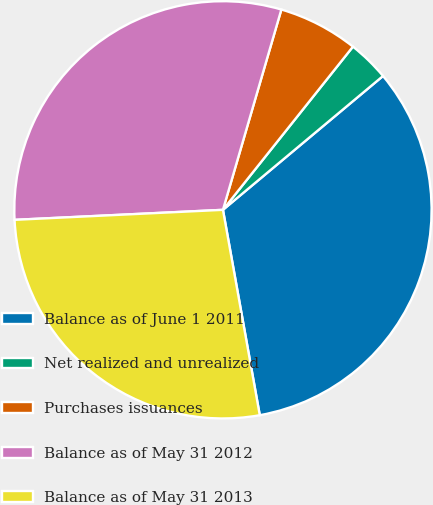Convert chart. <chart><loc_0><loc_0><loc_500><loc_500><pie_chart><fcel>Balance as of June 1 2011<fcel>Net realized and unrealized<fcel>Purchases issuances<fcel>Balance as of May 31 2012<fcel>Balance as of May 31 2013<nl><fcel>33.26%<fcel>3.21%<fcel>6.19%<fcel>30.28%<fcel>27.06%<nl></chart> 